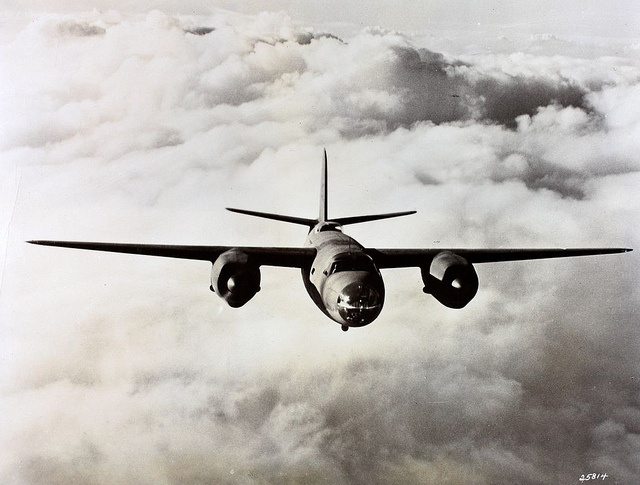Describe the objects in this image and their specific colors. I can see a airplane in lightgray, black, darkgray, and gray tones in this image. 